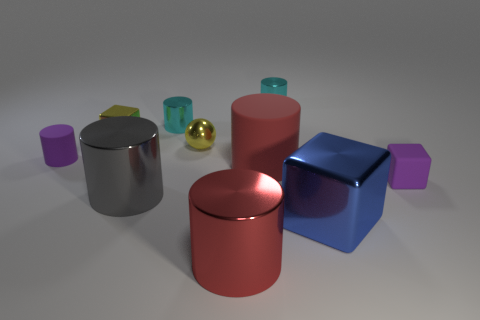Are there more tiny shiny blocks that are behind the small yellow cube than small rubber cylinders?
Make the answer very short. No. What number of cubes are to the left of the small purple object to the right of the small rubber thing to the left of the tiny rubber block?
Ensure brevity in your answer.  2. There is a gray metallic thing that is on the left side of the tiny matte cube; is it the same size as the purple matte object that is on the left side of the tiny yellow ball?
Your answer should be very brief. No. What is the tiny purple object that is on the left side of the small cyan shiny thing on the right side of the red shiny object made of?
Provide a short and direct response. Rubber. How many things are either shiny cylinders that are behind the sphere or small shiny spheres?
Offer a very short reply. 3. Are there the same number of large things that are behind the red matte object and big red matte things to the left of the small matte cylinder?
Your answer should be compact. Yes. The tiny cube that is on the right side of the big red cylinder that is in front of the red cylinder that is behind the gray object is made of what material?
Offer a terse response. Rubber. There is a block that is in front of the tiny ball and behind the gray object; what is its size?
Give a very brief answer. Small. Does the blue metallic object have the same shape as the big red shiny thing?
Provide a succinct answer. No. There is a big red object that is made of the same material as the large blue thing; what shape is it?
Make the answer very short. Cylinder. 